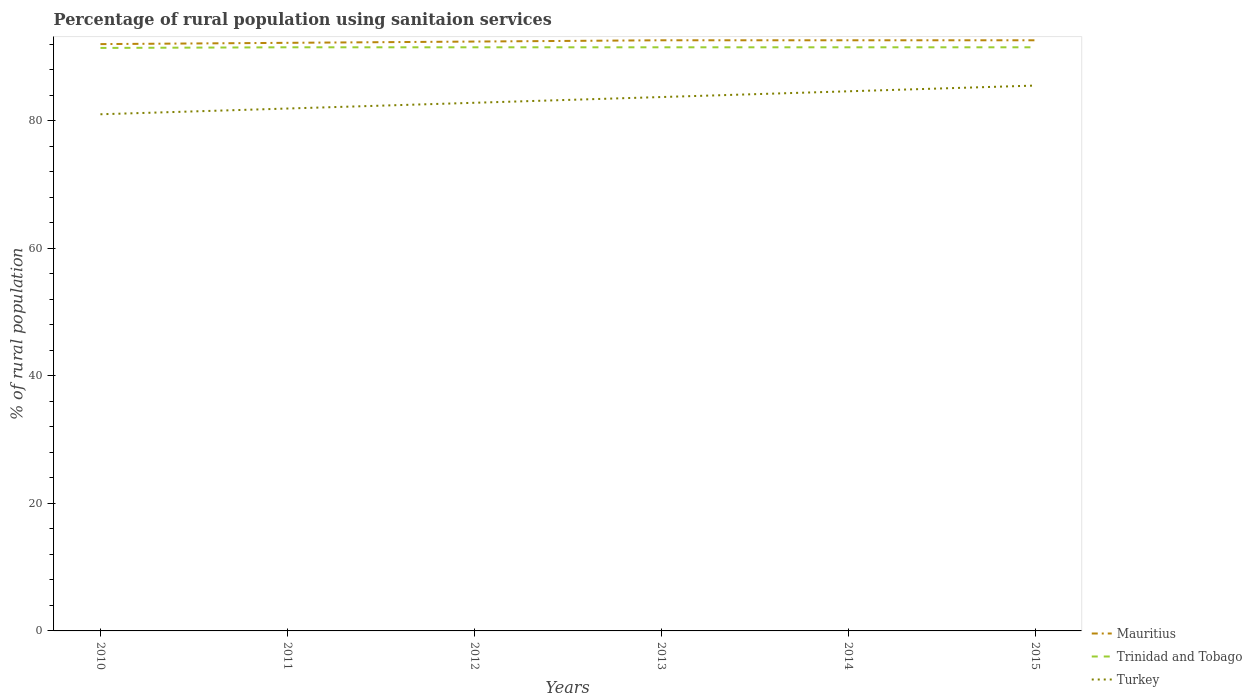How many different coloured lines are there?
Your response must be concise. 3. Does the line corresponding to Mauritius intersect with the line corresponding to Turkey?
Your answer should be compact. No. In which year was the percentage of rural population using sanitaion services in Turkey maximum?
Give a very brief answer. 2010. What is the total percentage of rural population using sanitaion services in Turkey in the graph?
Keep it short and to the point. -0.9. How many years are there in the graph?
Ensure brevity in your answer.  6. What is the difference between two consecutive major ticks on the Y-axis?
Your response must be concise. 20. Does the graph contain grids?
Offer a terse response. No. Where does the legend appear in the graph?
Provide a short and direct response. Bottom right. What is the title of the graph?
Keep it short and to the point. Percentage of rural population using sanitaion services. Does "Hungary" appear as one of the legend labels in the graph?
Offer a terse response. No. What is the label or title of the Y-axis?
Provide a succinct answer. % of rural population. What is the % of rural population in Mauritius in 2010?
Provide a short and direct response. 92. What is the % of rural population in Trinidad and Tobago in 2010?
Your response must be concise. 91.4. What is the % of rural population in Turkey in 2010?
Your answer should be very brief. 81. What is the % of rural population of Mauritius in 2011?
Your answer should be very brief. 92.2. What is the % of rural population in Trinidad and Tobago in 2011?
Provide a short and direct response. 91.5. What is the % of rural population in Turkey in 2011?
Ensure brevity in your answer.  81.9. What is the % of rural population in Mauritius in 2012?
Make the answer very short. 92.4. What is the % of rural population of Trinidad and Tobago in 2012?
Keep it short and to the point. 91.5. What is the % of rural population in Turkey in 2012?
Give a very brief answer. 82.8. What is the % of rural population in Mauritius in 2013?
Keep it short and to the point. 92.6. What is the % of rural population of Trinidad and Tobago in 2013?
Provide a short and direct response. 91.5. What is the % of rural population in Turkey in 2013?
Provide a succinct answer. 83.7. What is the % of rural population in Mauritius in 2014?
Provide a succinct answer. 92.6. What is the % of rural population in Trinidad and Tobago in 2014?
Offer a very short reply. 91.5. What is the % of rural population of Turkey in 2014?
Offer a terse response. 84.6. What is the % of rural population in Mauritius in 2015?
Provide a short and direct response. 92.6. What is the % of rural population in Trinidad and Tobago in 2015?
Offer a terse response. 91.5. What is the % of rural population in Turkey in 2015?
Your answer should be compact. 85.5. Across all years, what is the maximum % of rural population of Mauritius?
Keep it short and to the point. 92.6. Across all years, what is the maximum % of rural population in Trinidad and Tobago?
Provide a short and direct response. 91.5. Across all years, what is the maximum % of rural population of Turkey?
Ensure brevity in your answer.  85.5. Across all years, what is the minimum % of rural population of Mauritius?
Give a very brief answer. 92. Across all years, what is the minimum % of rural population in Trinidad and Tobago?
Your answer should be very brief. 91.4. Across all years, what is the minimum % of rural population in Turkey?
Keep it short and to the point. 81. What is the total % of rural population in Mauritius in the graph?
Offer a terse response. 554.4. What is the total % of rural population of Trinidad and Tobago in the graph?
Give a very brief answer. 548.9. What is the total % of rural population of Turkey in the graph?
Your response must be concise. 499.5. What is the difference between the % of rural population of Trinidad and Tobago in 2010 and that in 2011?
Your response must be concise. -0.1. What is the difference between the % of rural population in Turkey in 2010 and that in 2011?
Provide a succinct answer. -0.9. What is the difference between the % of rural population of Mauritius in 2010 and that in 2012?
Offer a terse response. -0.4. What is the difference between the % of rural population in Turkey in 2010 and that in 2012?
Offer a terse response. -1.8. What is the difference between the % of rural population in Mauritius in 2010 and that in 2013?
Give a very brief answer. -0.6. What is the difference between the % of rural population of Mauritius in 2010 and that in 2014?
Give a very brief answer. -0.6. What is the difference between the % of rural population in Trinidad and Tobago in 2010 and that in 2014?
Offer a terse response. -0.1. What is the difference between the % of rural population in Turkey in 2010 and that in 2014?
Ensure brevity in your answer.  -3.6. What is the difference between the % of rural population in Mauritius in 2010 and that in 2015?
Provide a short and direct response. -0.6. What is the difference between the % of rural population of Trinidad and Tobago in 2010 and that in 2015?
Provide a short and direct response. -0.1. What is the difference between the % of rural population in Turkey in 2010 and that in 2015?
Make the answer very short. -4.5. What is the difference between the % of rural population in Mauritius in 2012 and that in 2014?
Provide a short and direct response. -0.2. What is the difference between the % of rural population in Turkey in 2012 and that in 2014?
Give a very brief answer. -1.8. What is the difference between the % of rural population in Mauritius in 2012 and that in 2015?
Keep it short and to the point. -0.2. What is the difference between the % of rural population in Trinidad and Tobago in 2012 and that in 2015?
Offer a terse response. 0. What is the difference between the % of rural population of Mauritius in 2013 and that in 2014?
Provide a short and direct response. 0. What is the difference between the % of rural population of Turkey in 2013 and that in 2014?
Make the answer very short. -0.9. What is the difference between the % of rural population in Trinidad and Tobago in 2013 and that in 2015?
Make the answer very short. 0. What is the difference between the % of rural population in Mauritius in 2014 and that in 2015?
Give a very brief answer. 0. What is the difference between the % of rural population of Mauritius in 2010 and the % of rural population of Trinidad and Tobago in 2011?
Offer a very short reply. 0.5. What is the difference between the % of rural population of Mauritius in 2010 and the % of rural population of Trinidad and Tobago in 2012?
Provide a short and direct response. 0.5. What is the difference between the % of rural population in Mauritius in 2010 and the % of rural population in Turkey in 2012?
Your answer should be compact. 9.2. What is the difference between the % of rural population in Mauritius in 2010 and the % of rural population in Trinidad and Tobago in 2013?
Keep it short and to the point. 0.5. What is the difference between the % of rural population in Mauritius in 2010 and the % of rural population in Turkey in 2013?
Ensure brevity in your answer.  8.3. What is the difference between the % of rural population of Trinidad and Tobago in 2010 and the % of rural population of Turkey in 2013?
Your answer should be compact. 7.7. What is the difference between the % of rural population in Mauritius in 2010 and the % of rural population in Trinidad and Tobago in 2014?
Offer a terse response. 0.5. What is the difference between the % of rural population of Mauritius in 2010 and the % of rural population of Turkey in 2014?
Your answer should be very brief. 7.4. What is the difference between the % of rural population of Trinidad and Tobago in 2010 and the % of rural population of Turkey in 2014?
Offer a terse response. 6.8. What is the difference between the % of rural population in Mauritius in 2010 and the % of rural population in Turkey in 2015?
Give a very brief answer. 6.5. What is the difference between the % of rural population of Trinidad and Tobago in 2010 and the % of rural population of Turkey in 2015?
Keep it short and to the point. 5.9. What is the difference between the % of rural population in Mauritius in 2011 and the % of rural population in Trinidad and Tobago in 2012?
Ensure brevity in your answer.  0.7. What is the difference between the % of rural population in Trinidad and Tobago in 2011 and the % of rural population in Turkey in 2012?
Keep it short and to the point. 8.7. What is the difference between the % of rural population in Mauritius in 2011 and the % of rural population in Trinidad and Tobago in 2013?
Keep it short and to the point. 0.7. What is the difference between the % of rural population in Mauritius in 2011 and the % of rural population in Turkey in 2013?
Keep it short and to the point. 8.5. What is the difference between the % of rural population of Mauritius in 2011 and the % of rural population of Trinidad and Tobago in 2014?
Provide a succinct answer. 0.7. What is the difference between the % of rural population of Mauritius in 2011 and the % of rural population of Turkey in 2014?
Offer a very short reply. 7.6. What is the difference between the % of rural population in Mauritius in 2011 and the % of rural population in Turkey in 2015?
Give a very brief answer. 6.7. What is the difference between the % of rural population in Mauritius in 2012 and the % of rural population in Trinidad and Tobago in 2013?
Give a very brief answer. 0.9. What is the difference between the % of rural population of Mauritius in 2012 and the % of rural population of Turkey in 2013?
Provide a short and direct response. 8.7. What is the difference between the % of rural population of Trinidad and Tobago in 2012 and the % of rural population of Turkey in 2013?
Ensure brevity in your answer.  7.8. What is the difference between the % of rural population in Mauritius in 2012 and the % of rural population in Trinidad and Tobago in 2014?
Provide a short and direct response. 0.9. What is the difference between the % of rural population in Trinidad and Tobago in 2012 and the % of rural population in Turkey in 2014?
Keep it short and to the point. 6.9. What is the difference between the % of rural population in Mauritius in 2013 and the % of rural population in Trinidad and Tobago in 2014?
Provide a short and direct response. 1.1. What is the difference between the % of rural population of Mauritius in 2013 and the % of rural population of Turkey in 2014?
Provide a succinct answer. 8. What is the difference between the % of rural population in Trinidad and Tobago in 2013 and the % of rural population in Turkey in 2014?
Ensure brevity in your answer.  6.9. What is the difference between the % of rural population of Mauritius in 2013 and the % of rural population of Trinidad and Tobago in 2015?
Keep it short and to the point. 1.1. What is the difference between the % of rural population of Mauritius in 2014 and the % of rural population of Trinidad and Tobago in 2015?
Provide a short and direct response. 1.1. What is the difference between the % of rural population of Trinidad and Tobago in 2014 and the % of rural population of Turkey in 2015?
Offer a terse response. 6. What is the average % of rural population in Mauritius per year?
Your answer should be compact. 92.4. What is the average % of rural population in Trinidad and Tobago per year?
Ensure brevity in your answer.  91.48. What is the average % of rural population of Turkey per year?
Offer a very short reply. 83.25. In the year 2010, what is the difference between the % of rural population of Mauritius and % of rural population of Turkey?
Keep it short and to the point. 11. In the year 2010, what is the difference between the % of rural population in Trinidad and Tobago and % of rural population in Turkey?
Your answer should be compact. 10.4. In the year 2011, what is the difference between the % of rural population of Mauritius and % of rural population of Trinidad and Tobago?
Your answer should be very brief. 0.7. In the year 2012, what is the difference between the % of rural population of Mauritius and % of rural population of Turkey?
Ensure brevity in your answer.  9.6. In the year 2013, what is the difference between the % of rural population in Mauritius and % of rural population in Trinidad and Tobago?
Provide a succinct answer. 1.1. In the year 2014, what is the difference between the % of rural population of Mauritius and % of rural population of Trinidad and Tobago?
Provide a succinct answer. 1.1. In the year 2014, what is the difference between the % of rural population of Mauritius and % of rural population of Turkey?
Offer a very short reply. 8. In the year 2014, what is the difference between the % of rural population in Trinidad and Tobago and % of rural population in Turkey?
Make the answer very short. 6.9. In the year 2015, what is the difference between the % of rural population of Mauritius and % of rural population of Turkey?
Your answer should be very brief. 7.1. What is the ratio of the % of rural population in Mauritius in 2010 to that in 2011?
Your answer should be very brief. 1. What is the ratio of the % of rural population in Turkey in 2010 to that in 2012?
Provide a short and direct response. 0.98. What is the ratio of the % of rural population in Trinidad and Tobago in 2010 to that in 2013?
Make the answer very short. 1. What is the ratio of the % of rural population of Turkey in 2010 to that in 2013?
Offer a very short reply. 0.97. What is the ratio of the % of rural population in Mauritius in 2010 to that in 2014?
Make the answer very short. 0.99. What is the ratio of the % of rural population in Trinidad and Tobago in 2010 to that in 2014?
Your response must be concise. 1. What is the ratio of the % of rural population in Turkey in 2010 to that in 2014?
Provide a succinct answer. 0.96. What is the ratio of the % of rural population of Mauritius in 2010 to that in 2015?
Give a very brief answer. 0.99. What is the ratio of the % of rural population in Trinidad and Tobago in 2010 to that in 2015?
Your answer should be very brief. 1. What is the ratio of the % of rural population in Turkey in 2011 to that in 2012?
Your response must be concise. 0.99. What is the ratio of the % of rural population of Trinidad and Tobago in 2011 to that in 2013?
Offer a terse response. 1. What is the ratio of the % of rural population of Turkey in 2011 to that in 2013?
Provide a succinct answer. 0.98. What is the ratio of the % of rural population of Mauritius in 2011 to that in 2014?
Provide a short and direct response. 1. What is the ratio of the % of rural population in Trinidad and Tobago in 2011 to that in 2014?
Ensure brevity in your answer.  1. What is the ratio of the % of rural population in Turkey in 2011 to that in 2014?
Your answer should be very brief. 0.97. What is the ratio of the % of rural population of Mauritius in 2011 to that in 2015?
Keep it short and to the point. 1. What is the ratio of the % of rural population of Trinidad and Tobago in 2011 to that in 2015?
Your response must be concise. 1. What is the ratio of the % of rural population of Turkey in 2011 to that in 2015?
Provide a short and direct response. 0.96. What is the ratio of the % of rural population in Mauritius in 2012 to that in 2013?
Provide a short and direct response. 1. What is the ratio of the % of rural population in Turkey in 2012 to that in 2013?
Ensure brevity in your answer.  0.99. What is the ratio of the % of rural population in Mauritius in 2012 to that in 2014?
Offer a very short reply. 1. What is the ratio of the % of rural population in Trinidad and Tobago in 2012 to that in 2014?
Your response must be concise. 1. What is the ratio of the % of rural population of Turkey in 2012 to that in 2014?
Your answer should be compact. 0.98. What is the ratio of the % of rural population in Trinidad and Tobago in 2012 to that in 2015?
Offer a very short reply. 1. What is the ratio of the % of rural population in Turkey in 2012 to that in 2015?
Provide a succinct answer. 0.97. What is the ratio of the % of rural population of Trinidad and Tobago in 2013 to that in 2014?
Provide a short and direct response. 1. What is the ratio of the % of rural population in Mauritius in 2013 to that in 2015?
Your response must be concise. 1. What is the ratio of the % of rural population in Trinidad and Tobago in 2013 to that in 2015?
Your response must be concise. 1. What is the ratio of the % of rural population in Turkey in 2013 to that in 2015?
Keep it short and to the point. 0.98. What is the ratio of the % of rural population in Mauritius in 2014 to that in 2015?
Offer a very short reply. 1. What is the ratio of the % of rural population of Trinidad and Tobago in 2014 to that in 2015?
Keep it short and to the point. 1. What is the ratio of the % of rural population in Turkey in 2014 to that in 2015?
Keep it short and to the point. 0.99. What is the difference between the highest and the second highest % of rural population in Mauritius?
Ensure brevity in your answer.  0. What is the difference between the highest and the second highest % of rural population of Trinidad and Tobago?
Your answer should be very brief. 0. What is the difference between the highest and the second highest % of rural population in Turkey?
Give a very brief answer. 0.9. What is the difference between the highest and the lowest % of rural population of Mauritius?
Give a very brief answer. 0.6. What is the difference between the highest and the lowest % of rural population of Trinidad and Tobago?
Provide a short and direct response. 0.1. What is the difference between the highest and the lowest % of rural population of Turkey?
Ensure brevity in your answer.  4.5. 